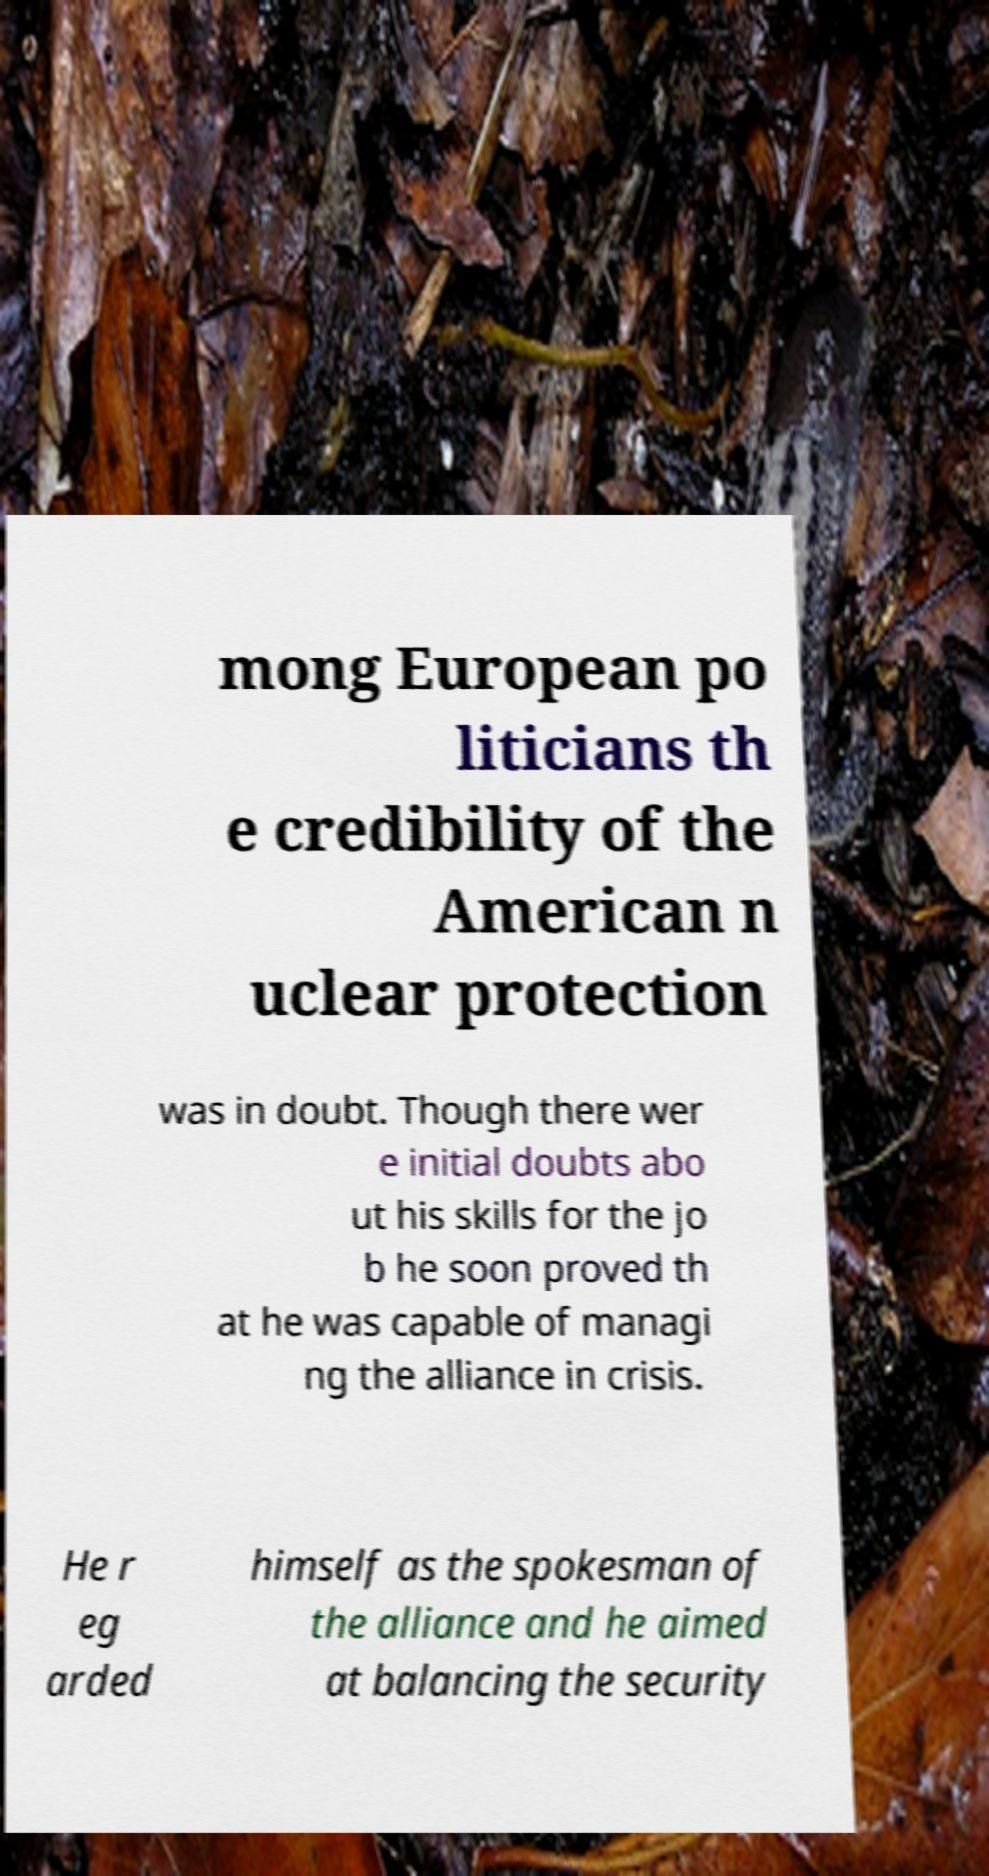What messages or text are displayed in this image? I need them in a readable, typed format. mong European po liticians th e credibility of the American n uclear protection was in doubt. Though there wer e initial doubts abo ut his skills for the jo b he soon proved th at he was capable of managi ng the alliance in crisis. He r eg arded himself as the spokesman of the alliance and he aimed at balancing the security 